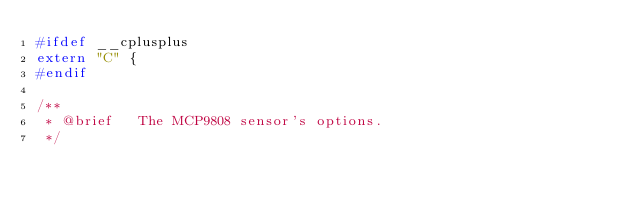Convert code to text. <code><loc_0><loc_0><loc_500><loc_500><_C_>#ifdef __cplusplus
extern "C" {
#endif

/**
 * @brief   The MCP9808 sensor's options. 
 */</code> 